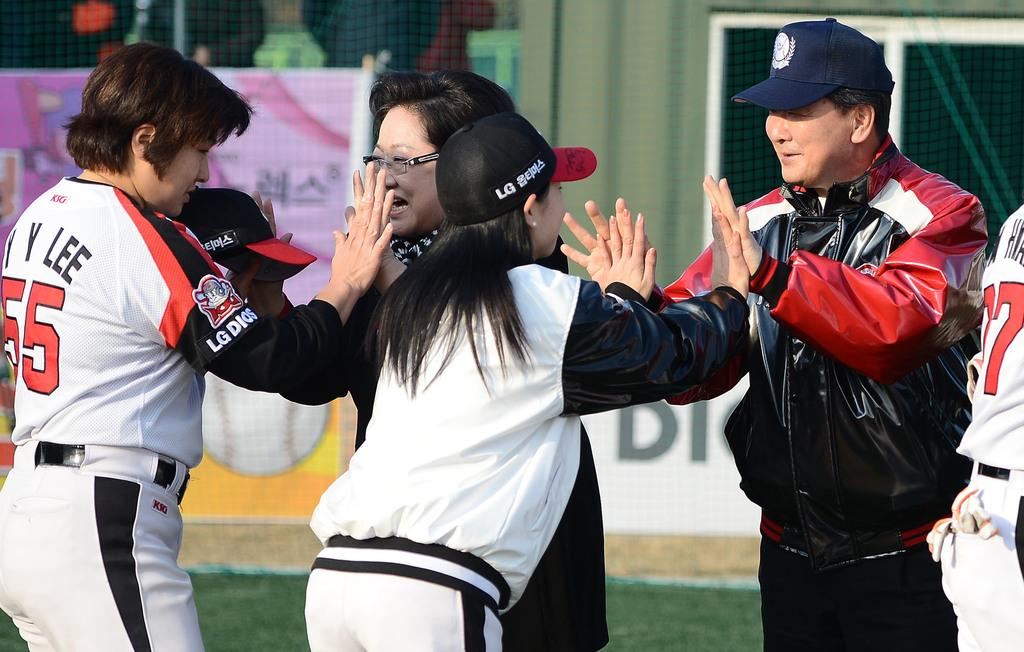<image>
Share a concise interpretation of the image provided. Several people in a group with one wearing number 55 on their backs. 